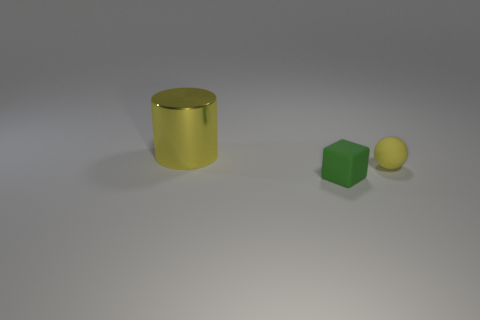Add 3 tiny cyan matte cubes. How many objects exist? 6 Subtract all spheres. How many objects are left? 2 Add 3 balls. How many balls are left? 4 Add 1 tiny blocks. How many tiny blocks exist? 2 Subtract 0 cyan cylinders. How many objects are left? 3 Subtract all small yellow blocks. Subtract all large shiny cylinders. How many objects are left? 2 